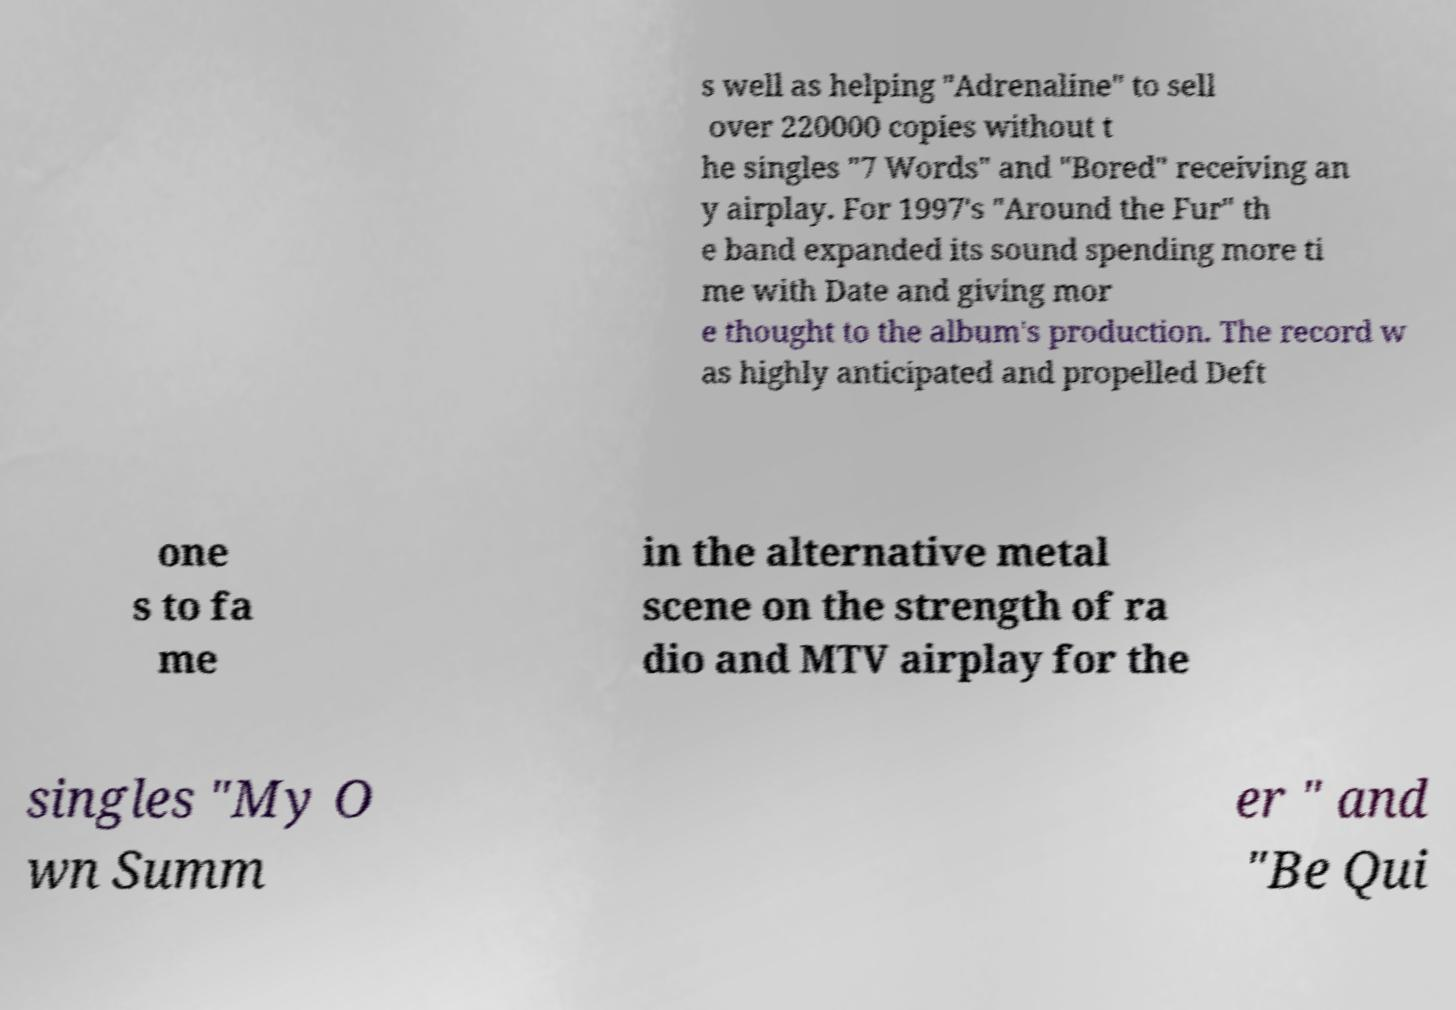For documentation purposes, I need the text within this image transcribed. Could you provide that? s well as helping "Adrenaline" to sell over 220000 copies without t he singles "7 Words" and "Bored" receiving an y airplay. For 1997's "Around the Fur" th e band expanded its sound spending more ti me with Date and giving mor e thought to the album's production. The record w as highly anticipated and propelled Deft one s to fa me in the alternative metal scene on the strength of ra dio and MTV airplay for the singles "My O wn Summ er " and "Be Qui 